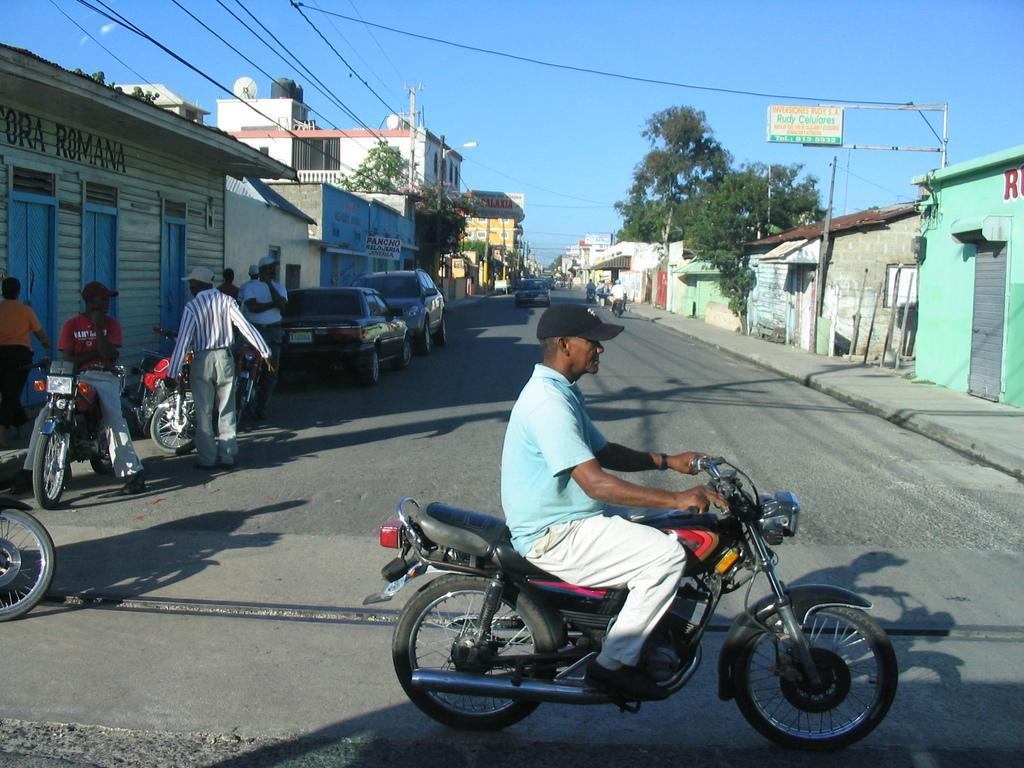In one or two sentences, can you explain what this image depicts? In the image we can see there is a person who is sitting on bike and there are other persons who are standing and cars are parked on the road. There are buildings and houses in the area there are trees in the locality. 